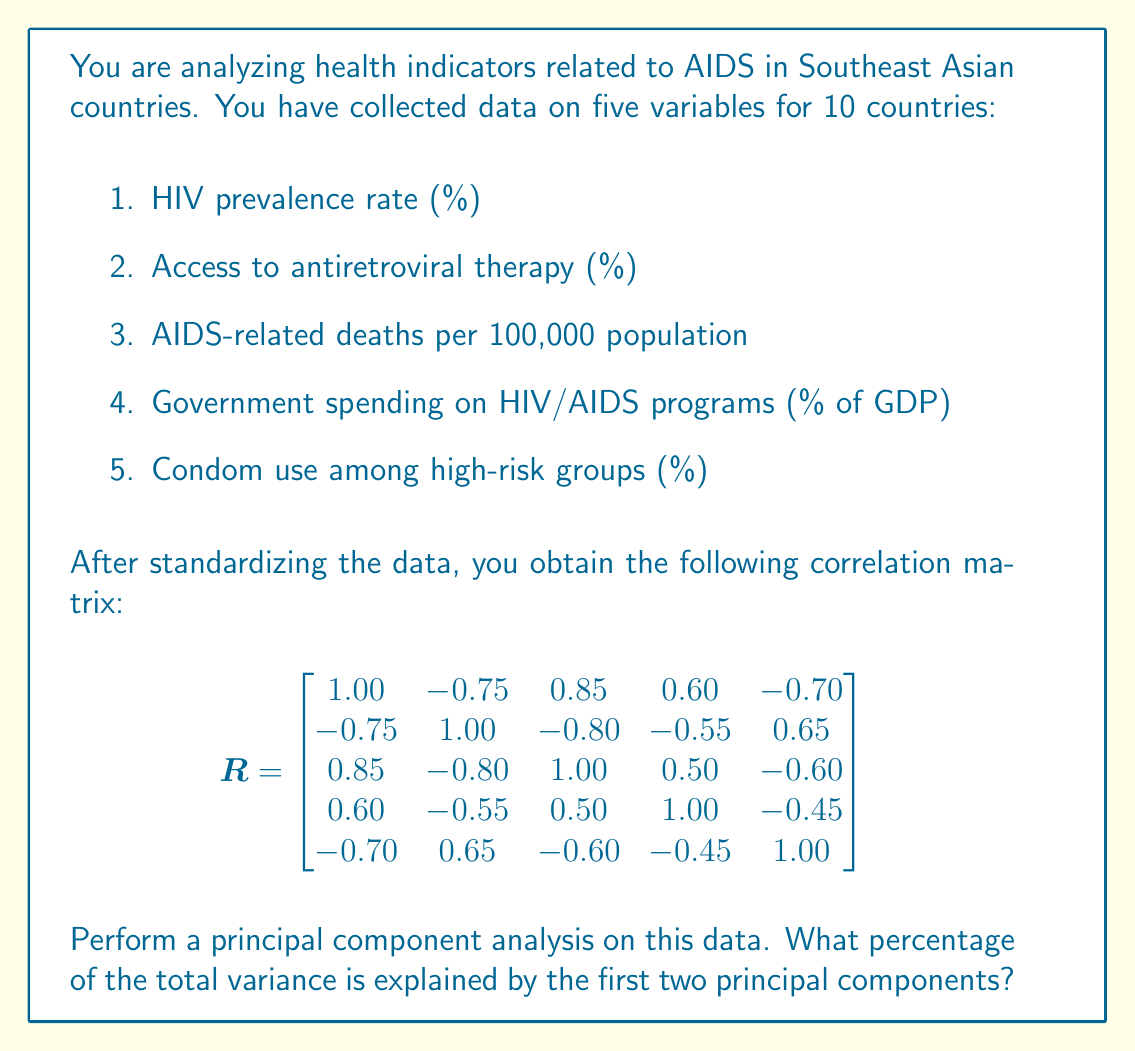Provide a solution to this math problem. To perform principal component analysis and determine the percentage of total variance explained by the first two principal components, we need to follow these steps:

1. Calculate the eigenvalues and eigenvectors of the correlation matrix R.

2. The eigenvalues represent the amount of variance explained by each principal component.

3. Calculate the total variance, which is the sum of all eigenvalues.

4. Calculate the percentage of variance explained by the first two principal components.

Step 1: Calculate eigenvalues
Using a numerical method or statistical software, we find the eigenvalues of R:

$$\lambda_1 = 3.7246$$
$$\lambda_2 = 0.7854$$
$$\lambda_3 = 0.2765$$
$$\lambda_4 = 0.1435$$
$$\lambda_5 = 0.0700$$

Step 2: Calculate total variance
The total variance is the sum of all eigenvalues:

$$\text{Total Variance} = \sum_{i=1}^5 \lambda_i = 3.7246 + 0.7854 + 0.2765 + 0.1435 + 0.0700 = 5$$

Note that the total variance equals the number of variables, which is expected for a correlation matrix.

Step 3: Calculate variance explained by first two principal components
The variance explained by the first two principal components is:

$$\text{Variance Explained} = \lambda_1 + \lambda_2 = 3.7246 + 0.7854 = 4.5100$$

Step 4: Calculate percentage of variance explained
The percentage of variance explained by the first two principal components is:

$$\text{Percentage} = \frac{\text{Variance Explained}}{\text{Total Variance}} \times 100\% = \frac{4.5100}{5} \times 100\% = 90.20\%$$

Therefore, the first two principal components explain 90.20% of the total variance in the data.
Answer: 90.20% 